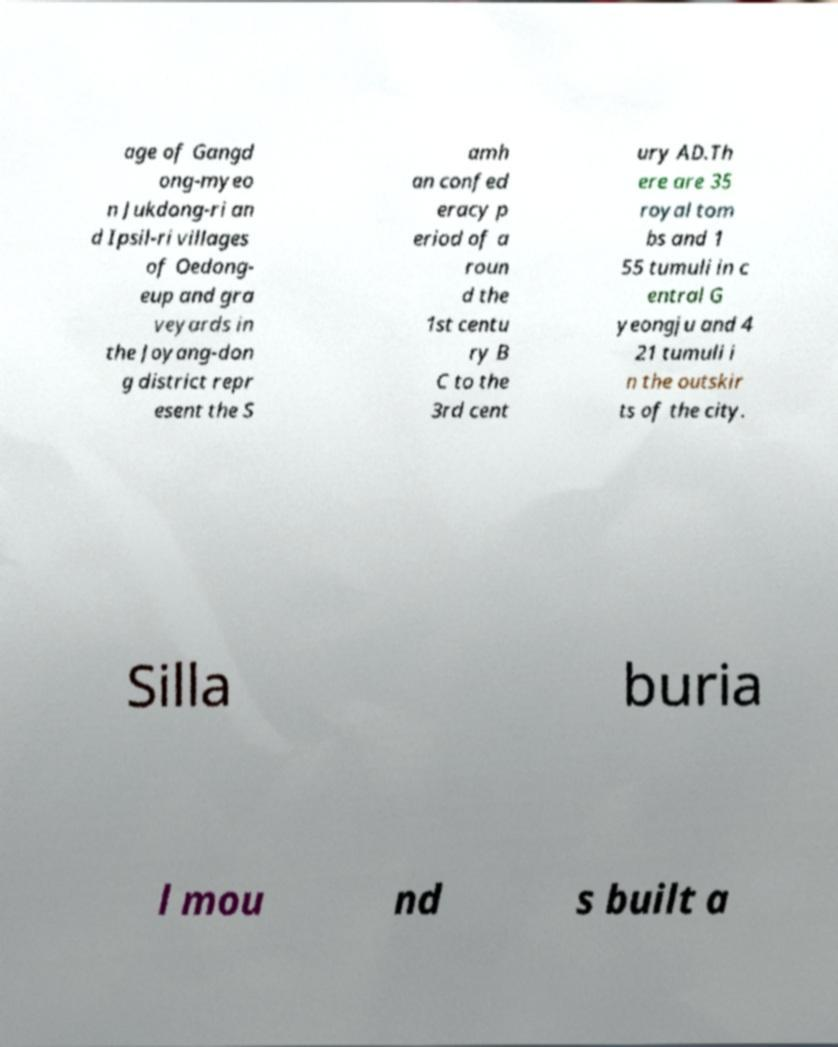There's text embedded in this image that I need extracted. Can you transcribe it verbatim? age of Gangd ong-myeo n Jukdong-ri an d Ipsil-ri villages of Oedong- eup and gra veyards in the Joyang-don g district repr esent the S amh an confed eracy p eriod of a roun d the 1st centu ry B C to the 3rd cent ury AD.Th ere are 35 royal tom bs and 1 55 tumuli in c entral G yeongju and 4 21 tumuli i n the outskir ts of the city. Silla buria l mou nd s built a 